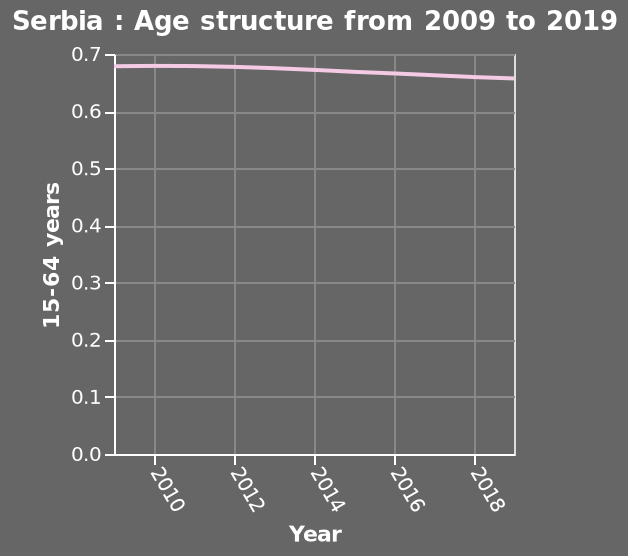<image>
please describe the details of the chart Serbia : Age structure from 2009 to 2019 is a line plot. There is a scale of range 0.0 to 0.7 along the y-axis, labeled 15-64 years. The x-axis plots Year. 